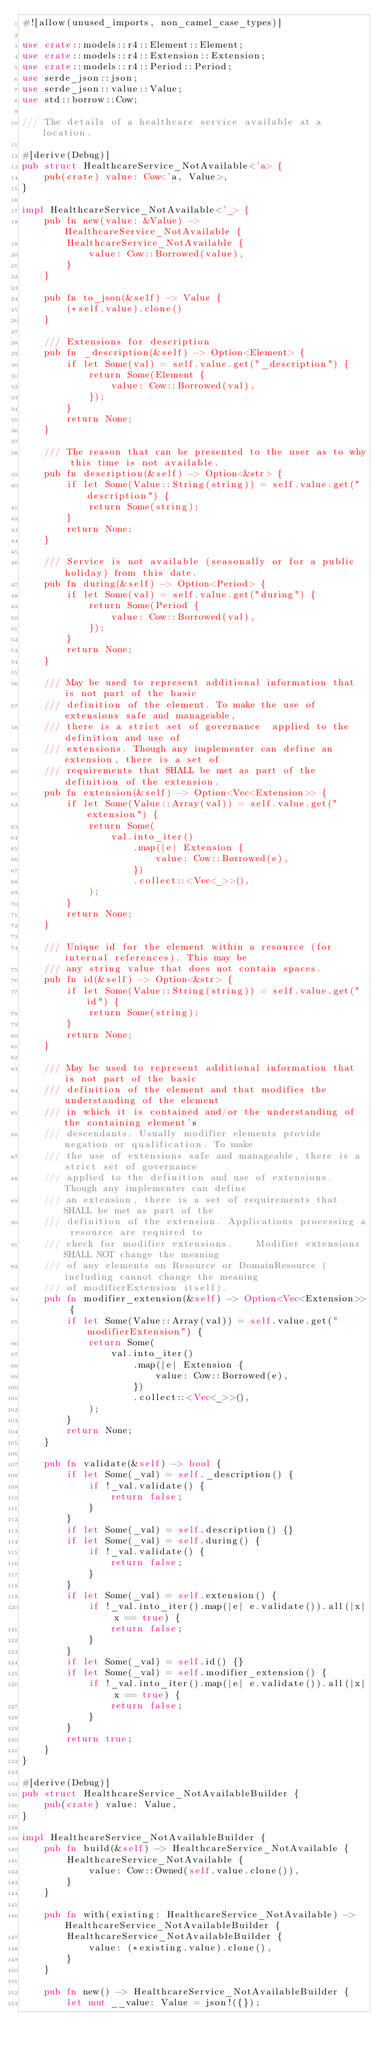Convert code to text. <code><loc_0><loc_0><loc_500><loc_500><_Rust_>#![allow(unused_imports, non_camel_case_types)]

use crate::models::r4::Element::Element;
use crate::models::r4::Extension::Extension;
use crate::models::r4::Period::Period;
use serde_json::json;
use serde_json::value::Value;
use std::borrow::Cow;

/// The details of a healthcare service available at a location.

#[derive(Debug)]
pub struct HealthcareService_NotAvailable<'a> {
    pub(crate) value: Cow<'a, Value>,
}

impl HealthcareService_NotAvailable<'_> {
    pub fn new(value: &Value) -> HealthcareService_NotAvailable {
        HealthcareService_NotAvailable {
            value: Cow::Borrowed(value),
        }
    }

    pub fn to_json(&self) -> Value {
        (*self.value).clone()
    }

    /// Extensions for description
    pub fn _description(&self) -> Option<Element> {
        if let Some(val) = self.value.get("_description") {
            return Some(Element {
                value: Cow::Borrowed(val),
            });
        }
        return None;
    }

    /// The reason that can be presented to the user as to why this time is not available.
    pub fn description(&self) -> Option<&str> {
        if let Some(Value::String(string)) = self.value.get("description") {
            return Some(string);
        }
        return None;
    }

    /// Service is not available (seasonally or for a public holiday) from this date.
    pub fn during(&self) -> Option<Period> {
        if let Some(val) = self.value.get("during") {
            return Some(Period {
                value: Cow::Borrowed(val),
            });
        }
        return None;
    }

    /// May be used to represent additional information that is not part of the basic
    /// definition of the element. To make the use of extensions safe and manageable,
    /// there is a strict set of governance  applied to the definition and use of
    /// extensions. Though any implementer can define an extension, there is a set of
    /// requirements that SHALL be met as part of the definition of the extension.
    pub fn extension(&self) -> Option<Vec<Extension>> {
        if let Some(Value::Array(val)) = self.value.get("extension") {
            return Some(
                val.into_iter()
                    .map(|e| Extension {
                        value: Cow::Borrowed(e),
                    })
                    .collect::<Vec<_>>(),
            );
        }
        return None;
    }

    /// Unique id for the element within a resource (for internal references). This may be
    /// any string value that does not contain spaces.
    pub fn id(&self) -> Option<&str> {
        if let Some(Value::String(string)) = self.value.get("id") {
            return Some(string);
        }
        return None;
    }

    /// May be used to represent additional information that is not part of the basic
    /// definition of the element and that modifies the understanding of the element
    /// in which it is contained and/or the understanding of the containing element's
    /// descendants. Usually modifier elements provide negation or qualification. To make
    /// the use of extensions safe and manageable, there is a strict set of governance
    /// applied to the definition and use of extensions. Though any implementer can define
    /// an extension, there is a set of requirements that SHALL be met as part of the
    /// definition of the extension. Applications processing a resource are required to
    /// check for modifier extensions.    Modifier extensions SHALL NOT change the meaning
    /// of any elements on Resource or DomainResource (including cannot change the meaning
    /// of modifierExtension itself).
    pub fn modifier_extension(&self) -> Option<Vec<Extension>> {
        if let Some(Value::Array(val)) = self.value.get("modifierExtension") {
            return Some(
                val.into_iter()
                    .map(|e| Extension {
                        value: Cow::Borrowed(e),
                    })
                    .collect::<Vec<_>>(),
            );
        }
        return None;
    }

    pub fn validate(&self) -> bool {
        if let Some(_val) = self._description() {
            if !_val.validate() {
                return false;
            }
        }
        if let Some(_val) = self.description() {}
        if let Some(_val) = self.during() {
            if !_val.validate() {
                return false;
            }
        }
        if let Some(_val) = self.extension() {
            if !_val.into_iter().map(|e| e.validate()).all(|x| x == true) {
                return false;
            }
        }
        if let Some(_val) = self.id() {}
        if let Some(_val) = self.modifier_extension() {
            if !_val.into_iter().map(|e| e.validate()).all(|x| x == true) {
                return false;
            }
        }
        return true;
    }
}

#[derive(Debug)]
pub struct HealthcareService_NotAvailableBuilder {
    pub(crate) value: Value,
}

impl HealthcareService_NotAvailableBuilder {
    pub fn build(&self) -> HealthcareService_NotAvailable {
        HealthcareService_NotAvailable {
            value: Cow::Owned(self.value.clone()),
        }
    }

    pub fn with(existing: HealthcareService_NotAvailable) -> HealthcareService_NotAvailableBuilder {
        HealthcareService_NotAvailableBuilder {
            value: (*existing.value).clone(),
        }
    }

    pub fn new() -> HealthcareService_NotAvailableBuilder {
        let mut __value: Value = json!({});</code> 